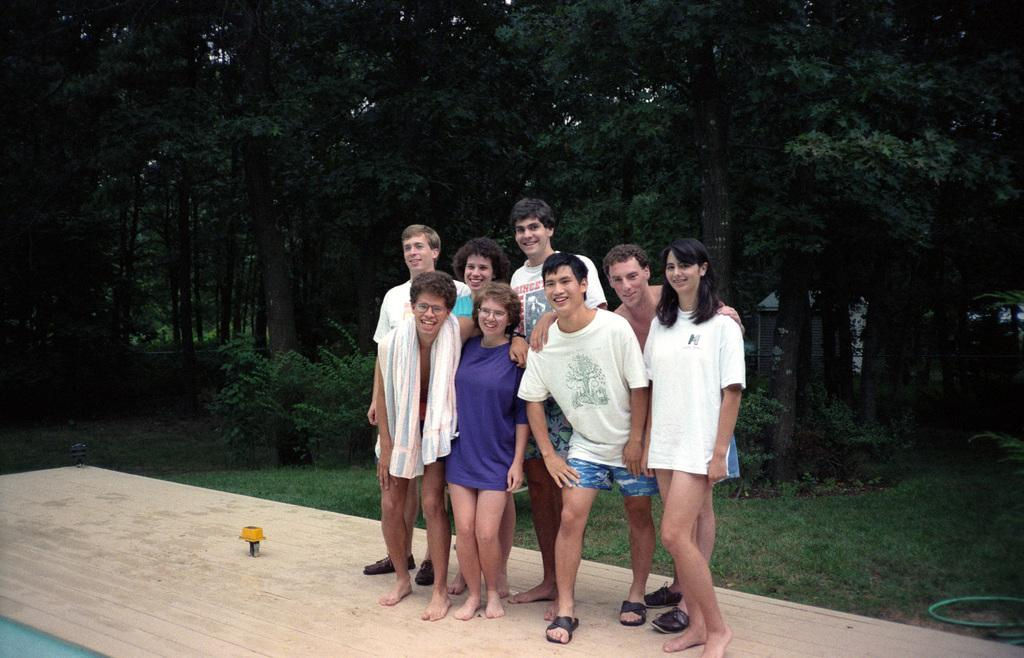How many people are in the image? There is a group of people in the image. What is the facial expression of the people in the image? The people are smiling. What can be seen in the background of the image? There are trees, plants, grass, and a house in the background of the image. What type of dinosaurs can be seen roaming in the background of the image? There are no dinosaurs present in the image; the background features trees, plants, grass, and a house. 